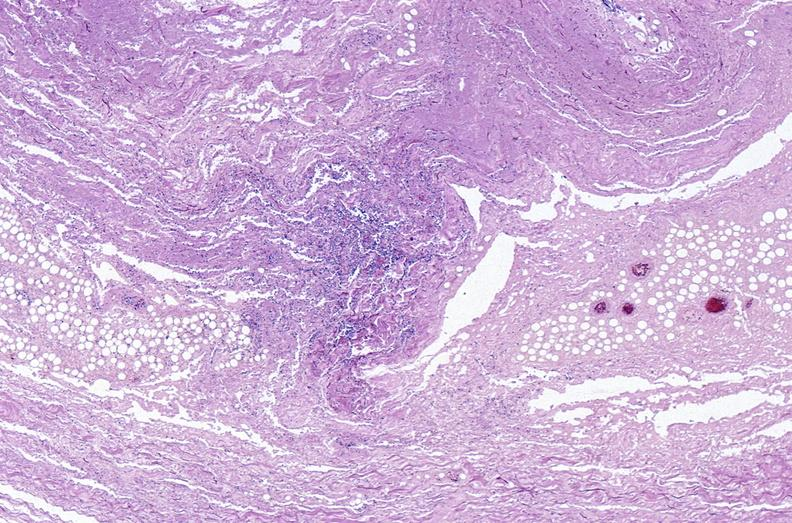where is this?
Answer the question using a single word or phrase. Skin 